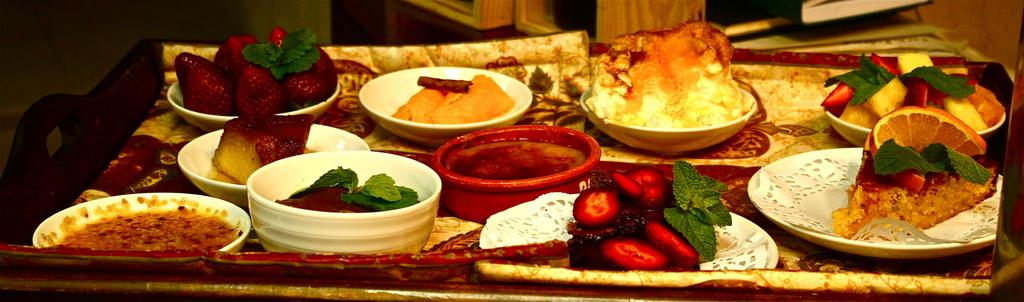What is the main object in the image? There is a tray in the image. What is on the tray? The tray contains bowls and plates. What is served on the bowls and plates? Different dishes are served on the bowls and plates. What else can be seen in the image? There are books at the top of the image and a cupboard. What type of canvas is visible in the image? There is no canvas present in the image. How comfortable is the floor in the image? The image does not show a floor, so it is not possible to determine its comfort level. 